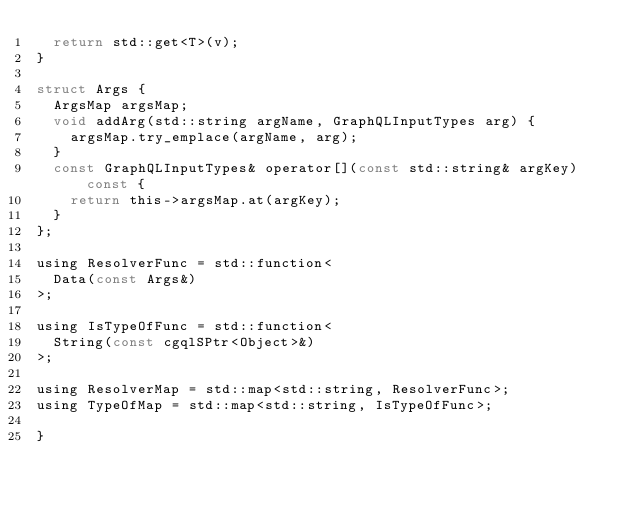<code> <loc_0><loc_0><loc_500><loc_500><_C_>  return std::get<T>(v);
}

struct Args {
  ArgsMap argsMap;
  void addArg(std::string argName, GraphQLInputTypes arg) {
    argsMap.try_emplace(argName, arg);
  }
  const GraphQLInputTypes& operator[](const std::string& argKey) const {
    return this->argsMap.at(argKey);
  }
};

using ResolverFunc = std::function<
  Data(const Args&)
>;

using IsTypeOfFunc = std::function<
  String(const cgqlSPtr<Object>&)
>;

using ResolverMap = std::map<std::string, ResolverFunc>;
using TypeOfMap = std::map<std::string, IsTypeOfFunc>;

}
</code> 